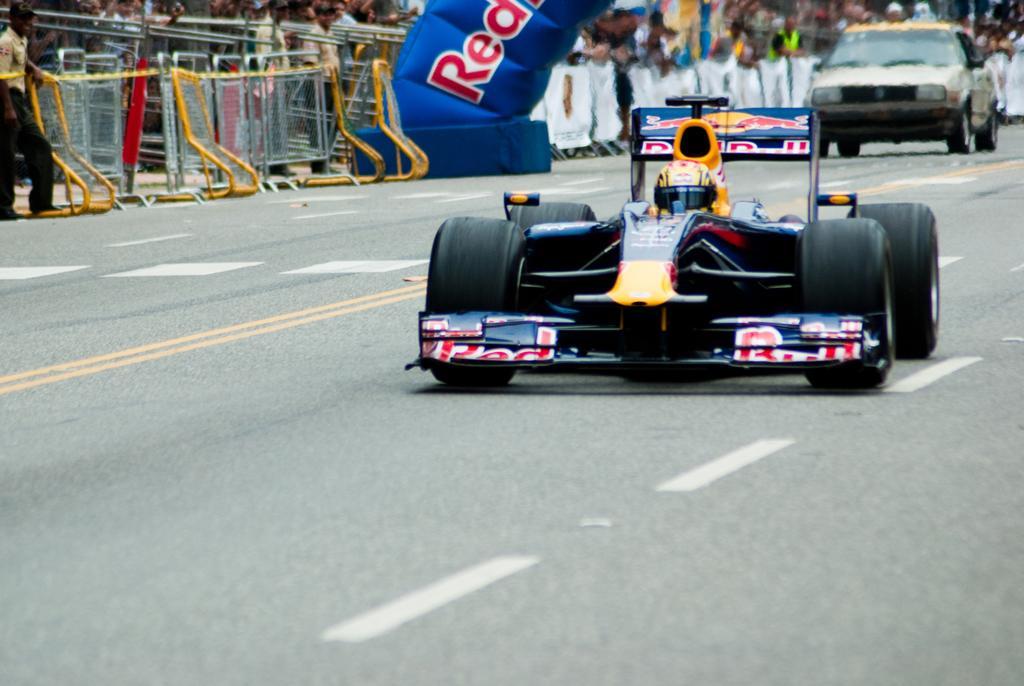Please provide a concise description of this image. In this picture we can see few vehicles are on the road, side we can see fencing, some people are standing and watching. 